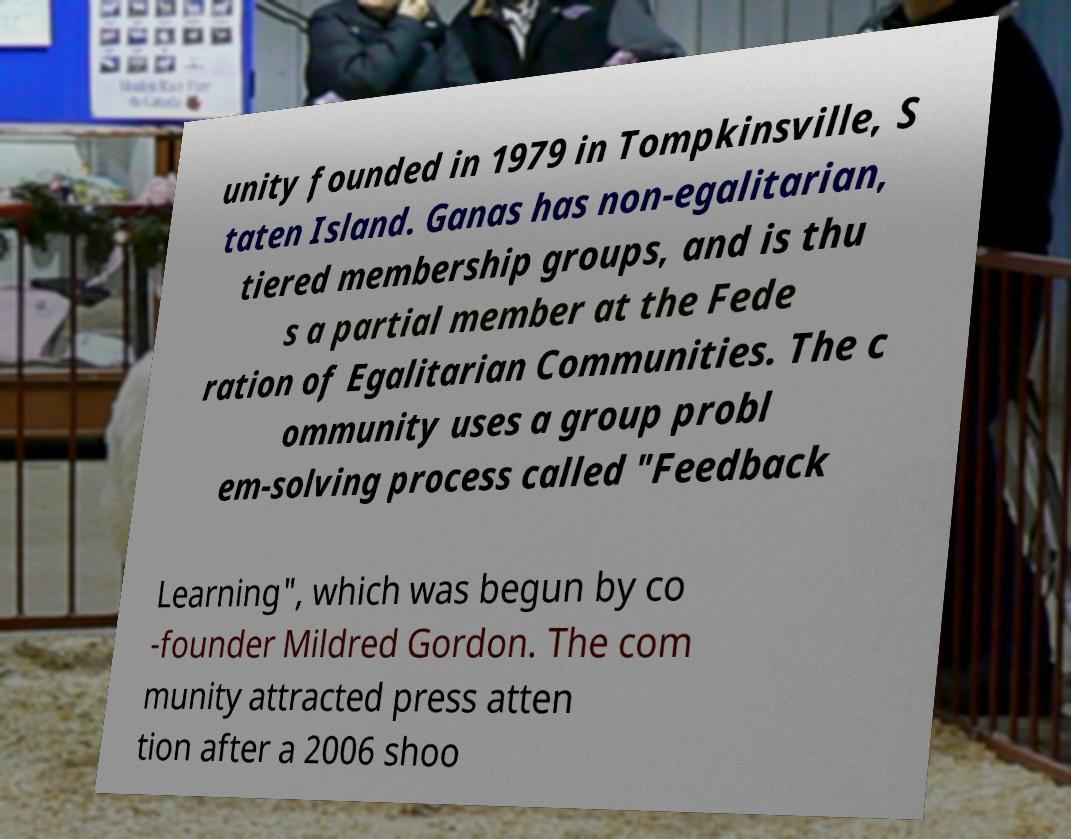Could you assist in decoding the text presented in this image and type it out clearly? unity founded in 1979 in Tompkinsville, S taten Island. Ganas has non-egalitarian, tiered membership groups, and is thu s a partial member at the Fede ration of Egalitarian Communities. The c ommunity uses a group probl em-solving process called "Feedback Learning", which was begun by co -founder Mildred Gordon. The com munity attracted press atten tion after a 2006 shoo 